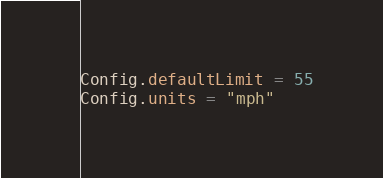<code> <loc_0><loc_0><loc_500><loc_500><_Lua_>Config.defaultLimit = 55
Config.units = "mph"
</code> 